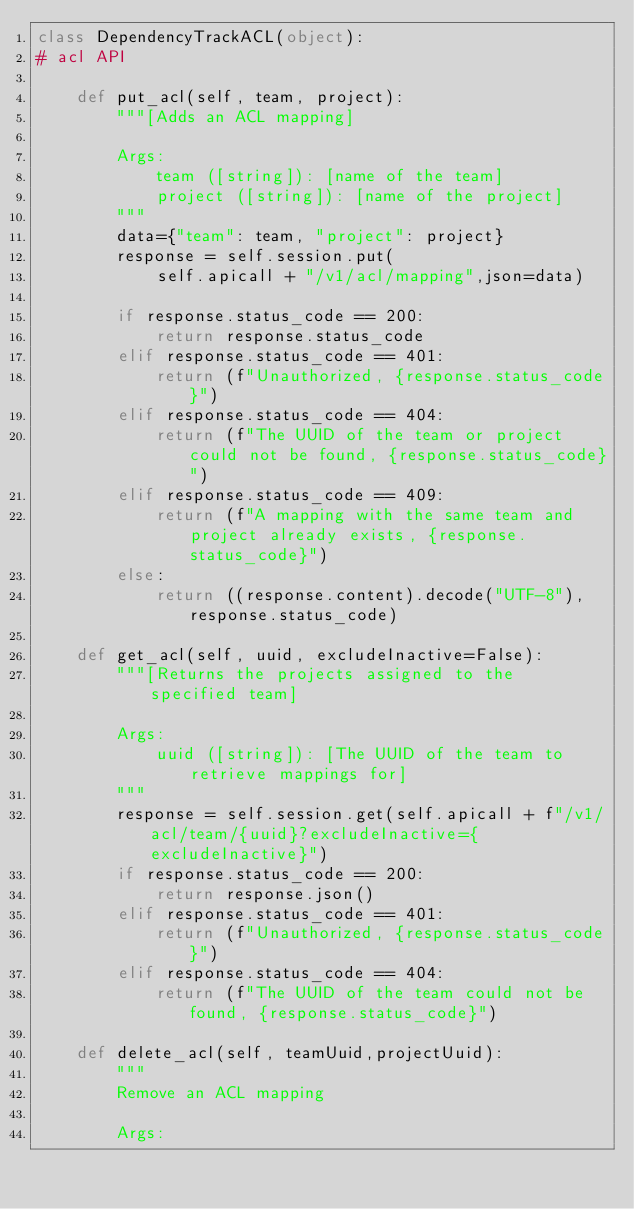Convert code to text. <code><loc_0><loc_0><loc_500><loc_500><_Python_>class DependencyTrackACL(object):
# acl API

    def put_acl(self, team, project):
        """[Adds an ACL mapping]

        Args:
            team ([string]): [name of the team]
            project ([string]): [name of the project]
        """
        data={"team": team, "project": project}
        response = self.session.put(
            self.apicall + "/v1/acl/mapping",json=data)

        if response.status_code == 200:
            return response.status_code
        elif response.status_code == 401:
            return (f"Unauthorized, {response.status_code}")
        elif response.status_code == 404:
            return (f"The UUID of the team or project could not be found, {response.status_code}")
        elif response.status_code == 409:
            return (f"A mapping with the same team and project already exists, {response.status_code}")
        else:
            return ((response.content).decode("UTF-8"), response.status_code)

    def get_acl(self, uuid, excludeInactive=False):
        """[Returns the projects assigned to the specified team]

        Args:
            uuid ([string]): [The UUID of the team to retrieve mappings for]
        """
        response = self.session.get(self.apicall + f"/v1/acl/team/{uuid}?excludeInactive={excludeInactive}")
        if response.status_code == 200:
            return response.json()
        elif response.status_code == 401:
            return (f"Unauthorized, {response.status_code}")
        elif response.status_code == 404:
            return (f"The UUID of the team could not be found, {response.status_code}")

    def delete_acl(self, teamUuid,projectUuid):
        """
        Remove an ACL mapping

        Args:</code> 